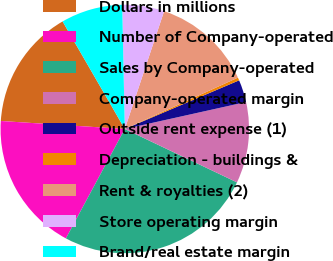Convert chart. <chart><loc_0><loc_0><loc_500><loc_500><pie_chart><fcel>Dollars in millions<fcel>Number of Company-operated<fcel>Sales by Company-operated<fcel>Company-operated margin<fcel>Outside rent expense (1)<fcel>Depreciation - buildings &<fcel>Rent & royalties (2)<fcel>Store operating margin<fcel>Brand/real estate margin<nl><fcel>15.63%<fcel>18.17%<fcel>25.79%<fcel>10.55%<fcel>2.92%<fcel>0.38%<fcel>13.09%<fcel>5.46%<fcel>8.01%<nl></chart> 